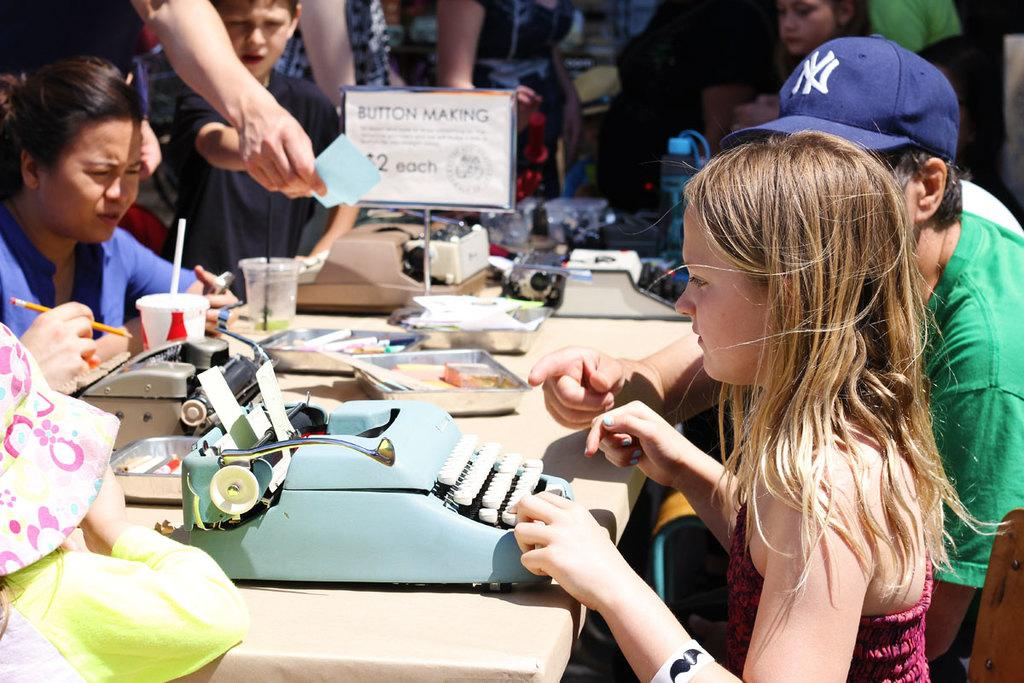What are the people in the image doing? There is a group of people sitting on chairs in the image. What is in front of the chairs? There is a table in front of the chairs. What can be seen on the table? There is a printer and glasses on the table. Are there any other objects on the table? Yes, there are other objects on the table. How much does the pain weigh in the image? There is no pain present in the image, so it cannot be weighed. 